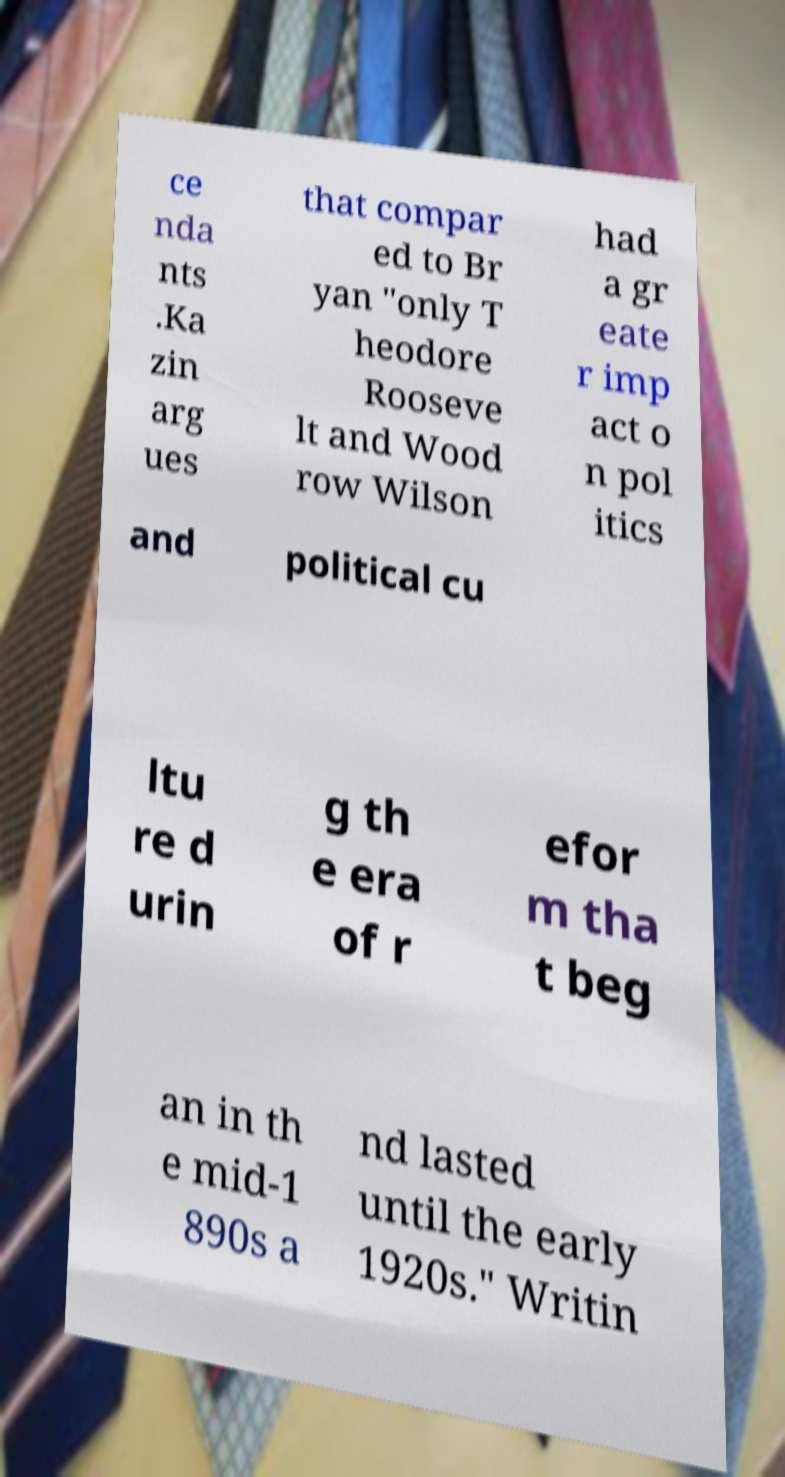For documentation purposes, I need the text within this image transcribed. Could you provide that? ce nda nts .Ka zin arg ues that compar ed to Br yan "only T heodore Rooseve lt and Wood row Wilson had a gr eate r imp act o n pol itics and political cu ltu re d urin g th e era of r efor m tha t beg an in th e mid-1 890s a nd lasted until the early 1920s." Writin 